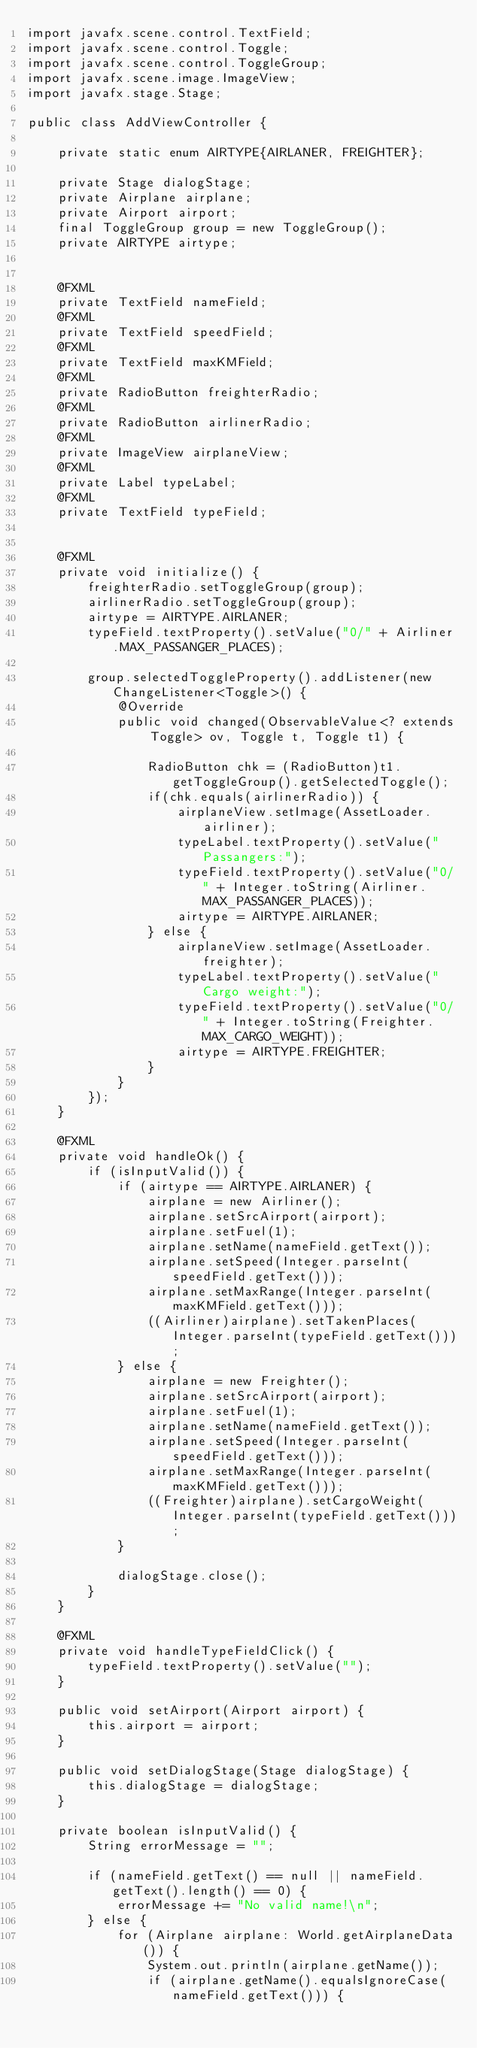Convert code to text. <code><loc_0><loc_0><loc_500><loc_500><_Java_>import javafx.scene.control.TextField;
import javafx.scene.control.Toggle;
import javafx.scene.control.ToggleGroup;
import javafx.scene.image.ImageView;
import javafx.stage.Stage;

public class AddViewController {

	private static enum AIRTYPE{AIRLANER, FREIGHTER};

	private Stage dialogStage;
    private Airplane airplane;
    private Airport airport;
    final ToggleGroup group = new ToggleGroup();
    private AIRTYPE airtype; 
   
    
    @FXML
    private TextField nameField;
    @FXML
    private TextField speedField;
    @FXML
    private TextField maxKMField;
    @FXML
    private RadioButton freighterRadio;
    @FXML
    private RadioButton airlinerRadio;
    @FXML
    private ImageView airplaneView;
    @FXML
    private Label typeLabel;
    @FXML
    private TextField typeField;
    
    
	@FXML
    private void initialize() {
		freighterRadio.setToggleGroup(group);
		airlinerRadio.setToggleGroup(group);
		airtype = AIRTYPE.AIRLANER;
    	typeField.textProperty().setValue("0/" + Airliner.MAX_PASSANGER_PLACES);
		
		group.selectedToggleProperty().addListener(new ChangeListener<Toggle>() {
	        @Override
	        public void changed(ObservableValue<? extends Toggle> ov, Toggle t, Toggle t1) {

	            RadioButton chk = (RadioButton)t1.getToggleGroup().getSelectedToggle();
	            if(chk.equals(airlinerRadio)) {
	            	airplaneView.setImage(AssetLoader.airliner);
	            	typeLabel.textProperty().setValue("Passangers:");
	            	typeField.textProperty().setValue("0/" + Integer.toString(Airliner.MAX_PASSANGER_PLACES));
	        		airtype = AIRTYPE.AIRLANER;
	            } else {
	            	airplaneView.setImage(AssetLoader.freighter);
	            	typeLabel.textProperty().setValue("Cargo weight:");
	            	typeField.textProperty().setValue("0/" + Integer.toString(Freighter.MAX_CARGO_WEIGHT));
	        		airtype = AIRTYPE.FREIGHTER;
	            }
	        }
	    });
    }

    @FXML
    private void handleOk() {
    	if (isInputValid()) {
    		if (airtype == AIRTYPE.AIRLANER) {
    			airplane = new Airliner();
    			airplane.setSrcAirport(airport);
            	airplane.setFuel(1);
            	airplane.setName(nameField.getText());
            	airplane.setSpeed(Integer.parseInt(speedField.getText()));
            	airplane.setMaxRange(Integer.parseInt(maxKMField.getText()));
            	((Airliner)airplane).setTakenPlaces(Integer.parseInt(typeField.getText()));
    		} else {
    			airplane = new Freighter();
    			airplane.setSrcAirport(airport);
            	airplane.setFuel(1);
            	airplane.setName(nameField.getText());
            	airplane.setSpeed(Integer.parseInt(speedField.getText()));
            	airplane.setMaxRange(Integer.parseInt(maxKMField.getText()));
            	((Freighter)airplane).setCargoWeight(Integer.parseInt(typeField.getText()));
    		}
    
            dialogStage.close();
    	}
    }
    
    @FXML
	private void handleTypeFieldClick() {
    	typeField.textProperty().setValue("");
    }
    
    public void setAirport(Airport airport) {
    	this.airport = airport;
    }
    
    public void setDialogStage(Stage dialogStage) {
        this.dialogStage = dialogStage;
    }
    
	private boolean isInputValid() {
        String errorMessage = "";

        if (nameField.getText() == null || nameField.getText().length() == 0) {
            errorMessage += "No valid name!\n"; 
        } else {
        	for (Airplane airplane: World.getAirplaneData()) {
        		System.out.println(airplane.getName());
        		if (airplane.getName().equalsIgnoreCase(nameField.getText())) {</code> 